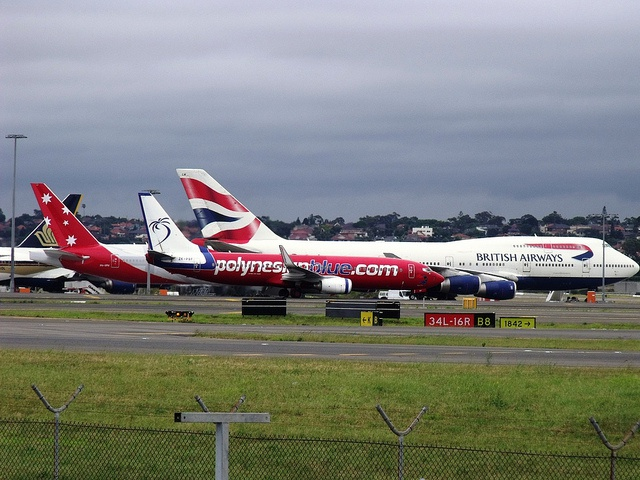Describe the objects in this image and their specific colors. I can see airplane in darkgray, white, black, and brown tones, airplane in darkgray, black, white, maroon, and brown tones, airplane in darkgray, black, white, and gray tones, truck in darkgray, lightgray, black, and gray tones, and truck in darkgray, lightgray, and gray tones in this image. 